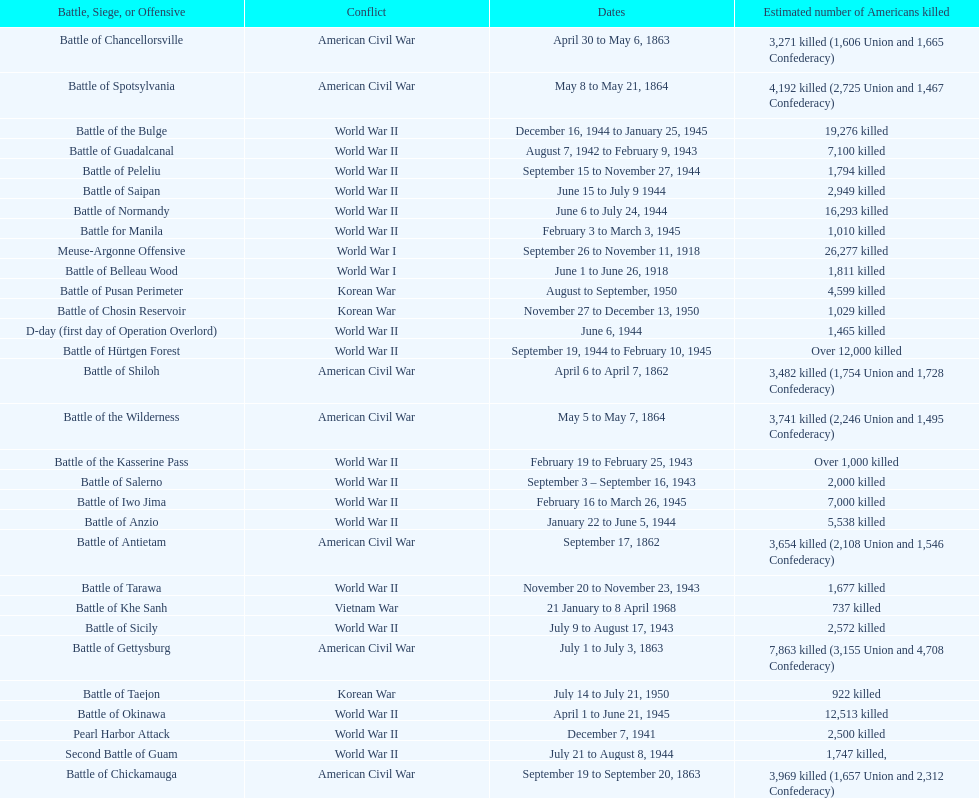How many battles resulted between 3,000 and 4,200 estimated americans killed? 6. 